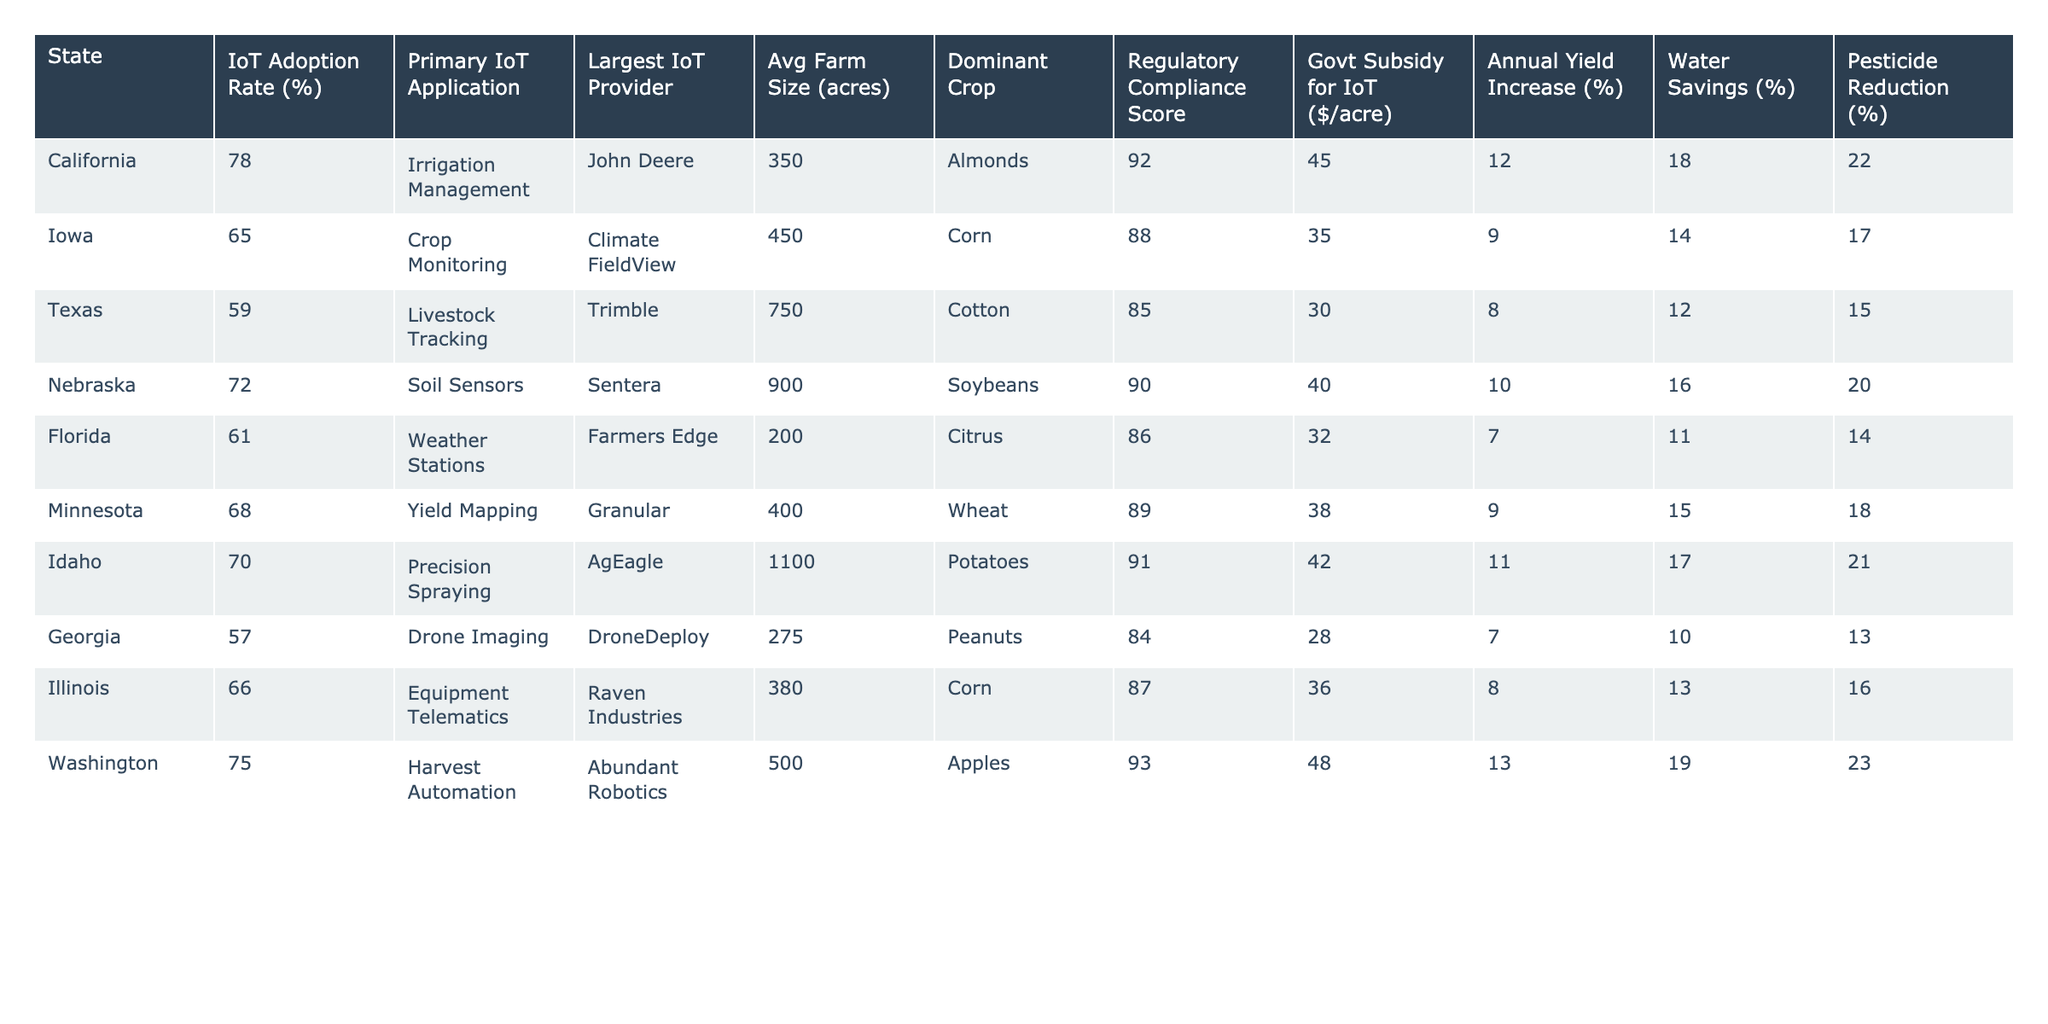What is the IoT adoption rate in California? The table lists California's IoT adoption rate, which is directly provided. California has an IoT adoption rate of 78%.
Answer: 78% Which state has the highest average farm size? The table shows the average farm sizes for each state, with Texas having the largest at 750 acres.
Answer: Texas What is the primary IoT application in Iowa? The primary IoT application in Iowa is specified in the table, indicating that it is Crop Monitoring.
Answer: Crop Monitoring Which state has the highest regulatory compliance score? Comparing the regulatory compliance scores in the table, California stands out with a score of 92, the highest among all listed states.
Answer: California What is the difference between the IoT adoption rate in Florida and Georgia? Florida's IoT adoption rate is 61%, and Georgia's rate is 57%. The difference is calculated as 61 - 57 = 4.
Answer: 4% Which state has the lowest annual yield increase percentage? By examining the annual yield increase percentages in the table, Florida's value is at 7%, which is the lowest among the states listed.
Answer: Florida Is the largest IoT provider for Nebraska listed in the table? The table specifies Sentera as the largest IoT provider for Nebraska, confirming that it is indeed listed.
Answer: Yes What is the average regulatory compliance score for states with an IoT adoption rate above 70%? States above 70% are California (92), Nebraska (90), Idaho (91), and Washington (93). The average compliance score is (92 + 90 + 91 + 93) / 4 = 91.5.
Answer: 91.5 Which dominating crop has the highest yield increase percentage? The data indicates that Idaho, with potatoes as the dominant crop, shows an annual yield increase of 11%, which is the highest among the dominant crops listed.
Answer: Potatoes Which state receives the most government subsidy per acre for IoT implementation? By checking the government subsidy column, California receives 45$/acre, which is the highest value listed in the table.
Answer: California Among all listed states, which has the highest percentage for pesticide reduction? The highest percentage for pesticide reduction is found in California, which is 22%, making it the leading state in this category.
Answer: California What is the average annual yield increase percentage for states that primarily grow corn? Illinois (8%) and Iowa (9%) are the only states primarily growing corn. The average is (8 + 9) / 2 = 8.5%.
Answer: 8.5% Are there any states that have an IoT adoption rate below 60%? By reviewing the table, Texas (59%) and Georgia (57%) both have adoption rates below 60%, confirming that there are states with such rates.
Answer: Yes 